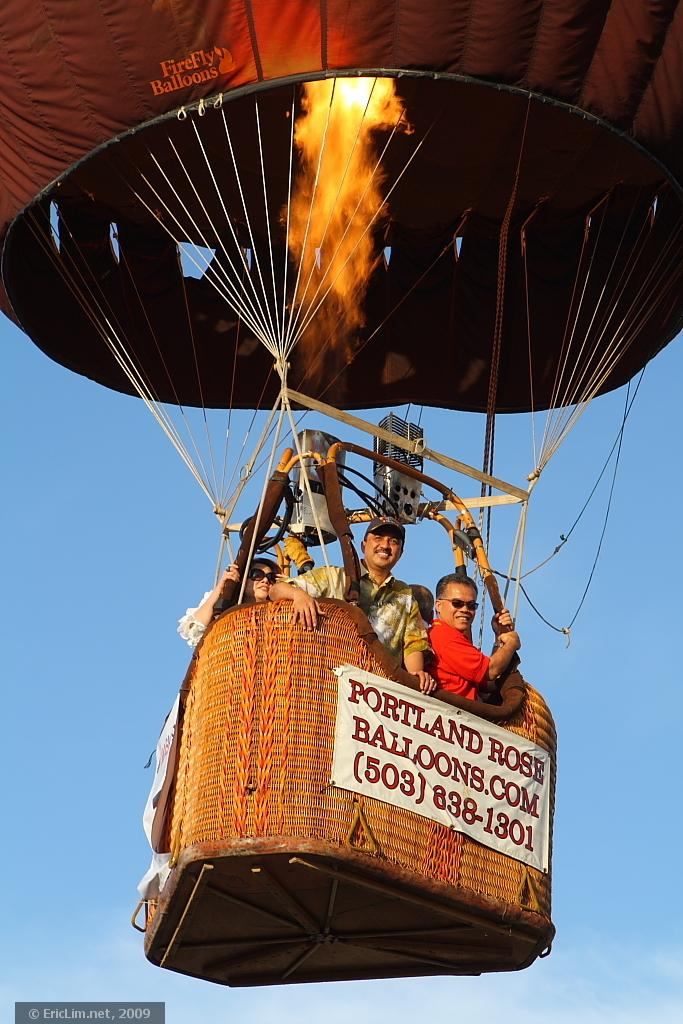<image>
Share a concise interpretation of the image provided. A group of people are taking a balloon ride from Portland Rose Balloons.com. 